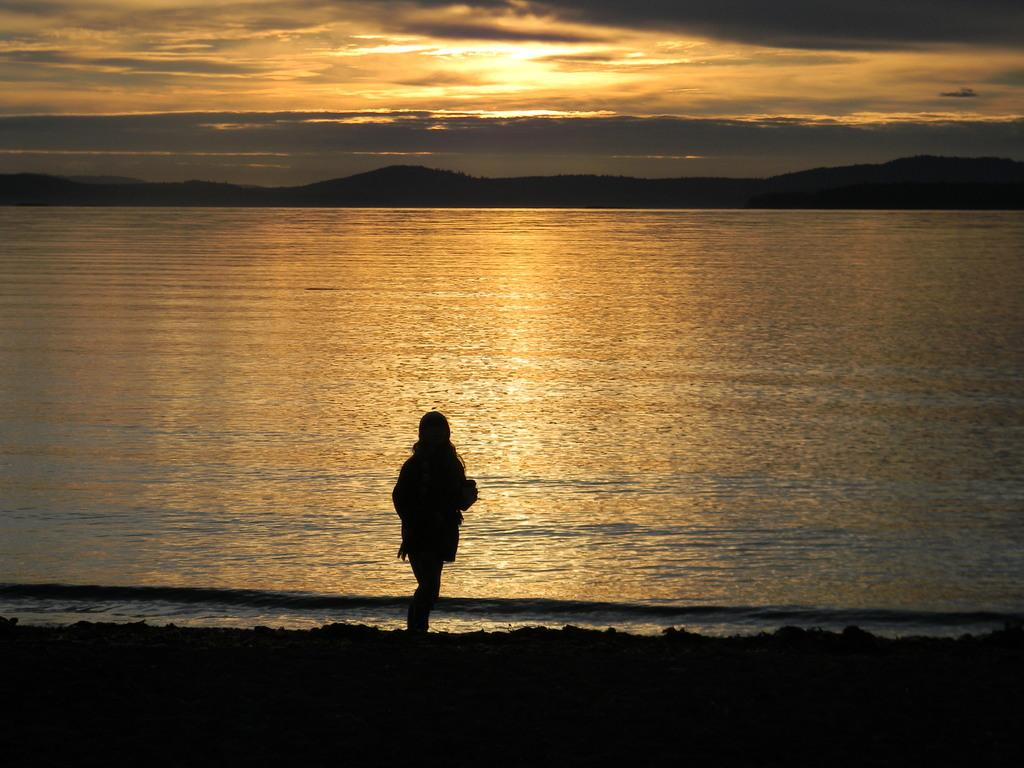What is the main subject of the image? There is a person standing in the image. What can be seen in the background behind the person? There is a lake visible behind the person, and hills can be seen behind the lake. How would you describe the sky in the image? The sky is cloudy in the image. What type of soap is being used to create the smoke in the image? There is no soap or smoke present in the image; it features a person standing in front of a lake and hills with a cloudy sky. 